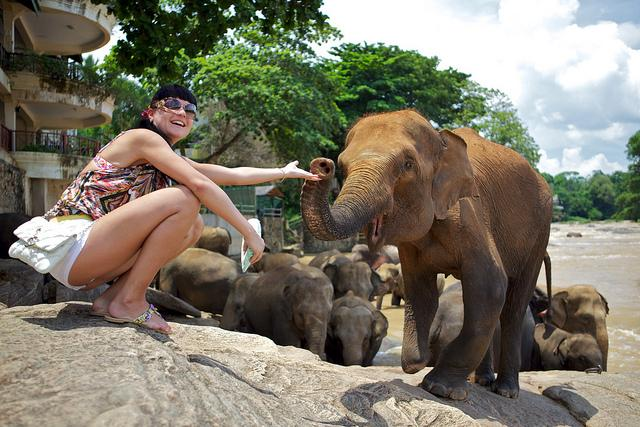What is climbing up the rocks to talk to the woman who is on the top? Please explain your reasoning. elephant. A large animal with a trunk approaches a girl. 